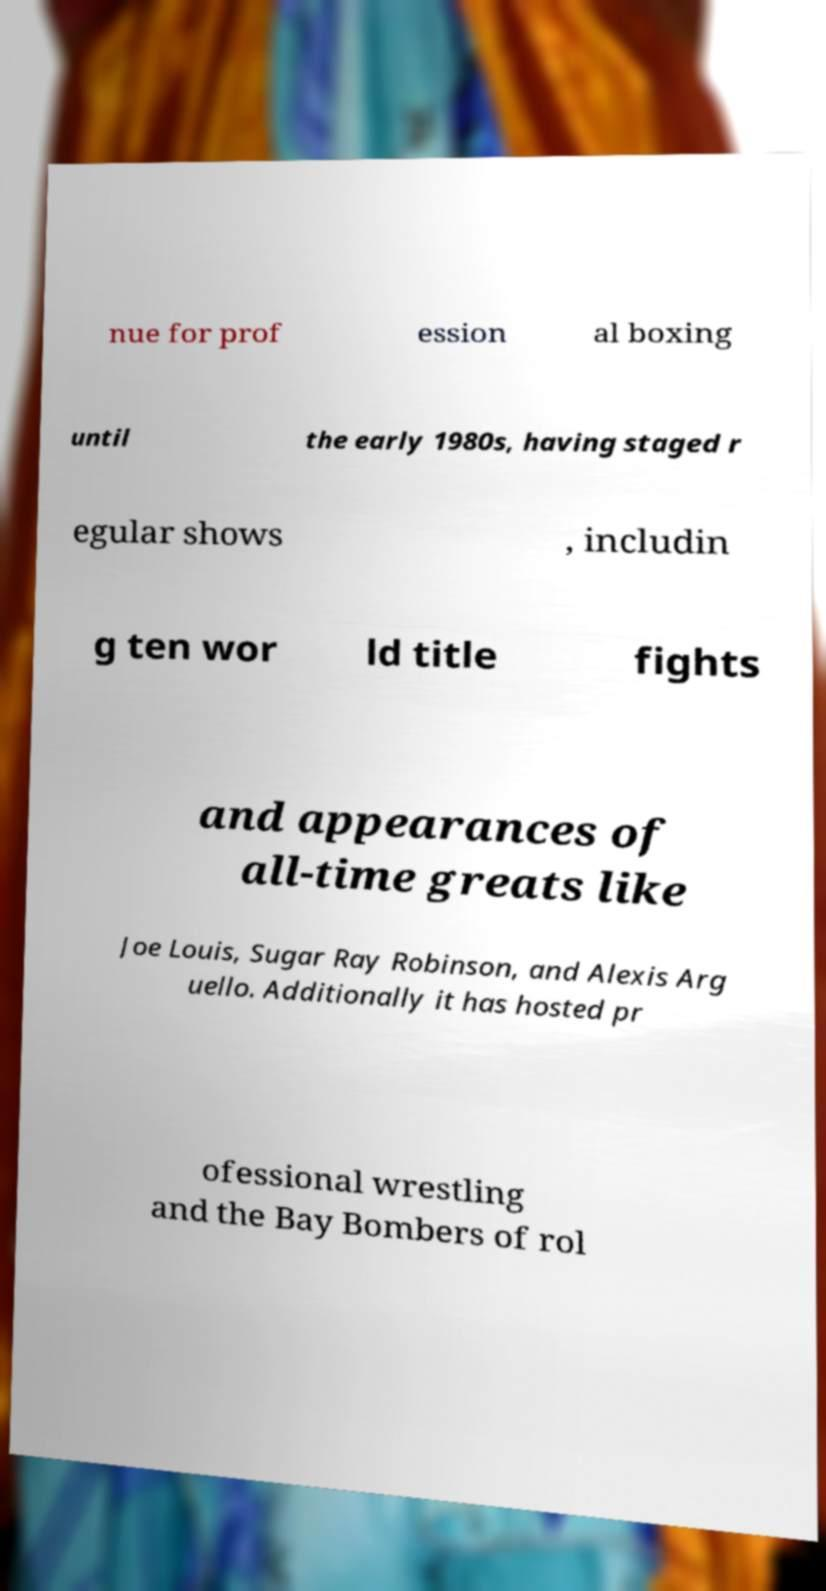Please read and relay the text visible in this image. What does it say? nue for prof ession al boxing until the early 1980s, having staged r egular shows , includin g ten wor ld title fights and appearances of all-time greats like Joe Louis, Sugar Ray Robinson, and Alexis Arg uello. Additionally it has hosted pr ofessional wrestling and the Bay Bombers of rol 